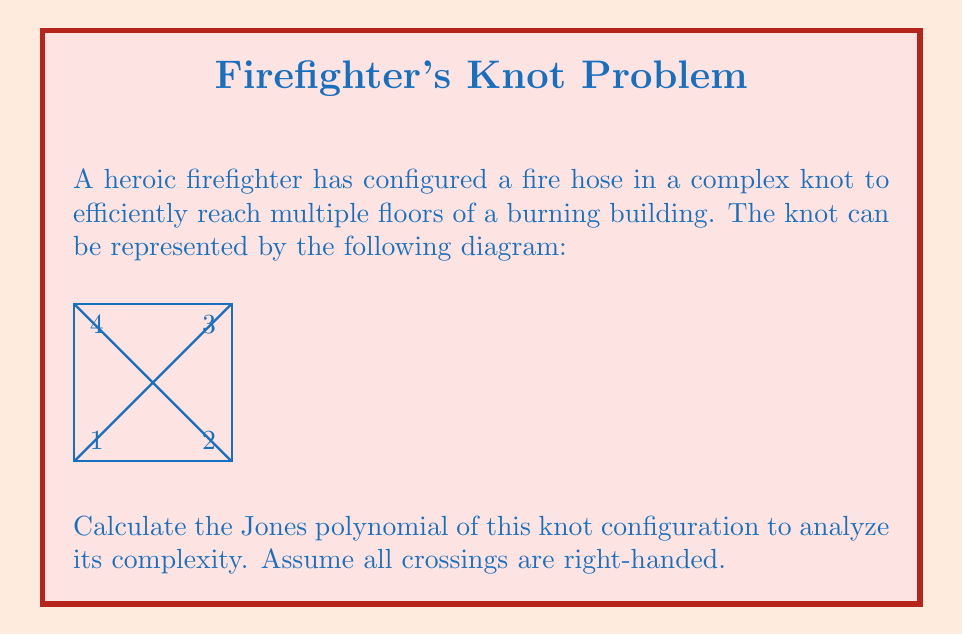Can you solve this math problem? To calculate the Jones polynomial of this knot, we'll follow these steps:

1) First, we need to identify the number of crossings. In this diagram, we have 4 crossings.

2) We'll use the skein relation for the Jones polynomial:

   $$t^{-1}V(L_+) - tV(L_-) = (t^{1/2} - t^{-1/2})V(L_0)$$

   where $L_+$, $L_-$, and $L_0$ represent positive crossing, negative crossing, and no crossing respectively.

3) We'll start by resolving one of the crossings. Let's choose the top-right crossing (labeled 3).

4) Resolving this crossing gives us two simpler knots:
   - $L_0$: A simple unknot (circle)
   - $L_-$: A trefoil knot

5) The Jones polynomial for an unknot is 1, and for a right-handed trefoil is:

   $$V(\text{trefoil}) = t + t^3 - t^4$$

6) Applying the skein relation:

   $$t^{-1}V(L_+) - t(t + t^3 - t^4) = (t^{1/2} - t^{-1/2})(1)$$

7) Simplifying:

   $$t^{-1}V(L_+) - (t^2 + t^4 - t^5) = t^{1/2} - t^{-1/2}$$

8) Multiplying both sides by $t$:

   $$V(L_+) - (t^3 + t^5 - t^6) = t^{3/2} - t^{1/2}$$

9) Solving for $V(L_+)$:

   $$V(L_+) = t^3 + t^5 - t^6 + t^{3/2} - t^{1/2}$$

This is the Jones polynomial for the given knot configuration.
Answer: $t^3 + t^5 - t^6 + t^{3/2} - t^{1/2}$ 